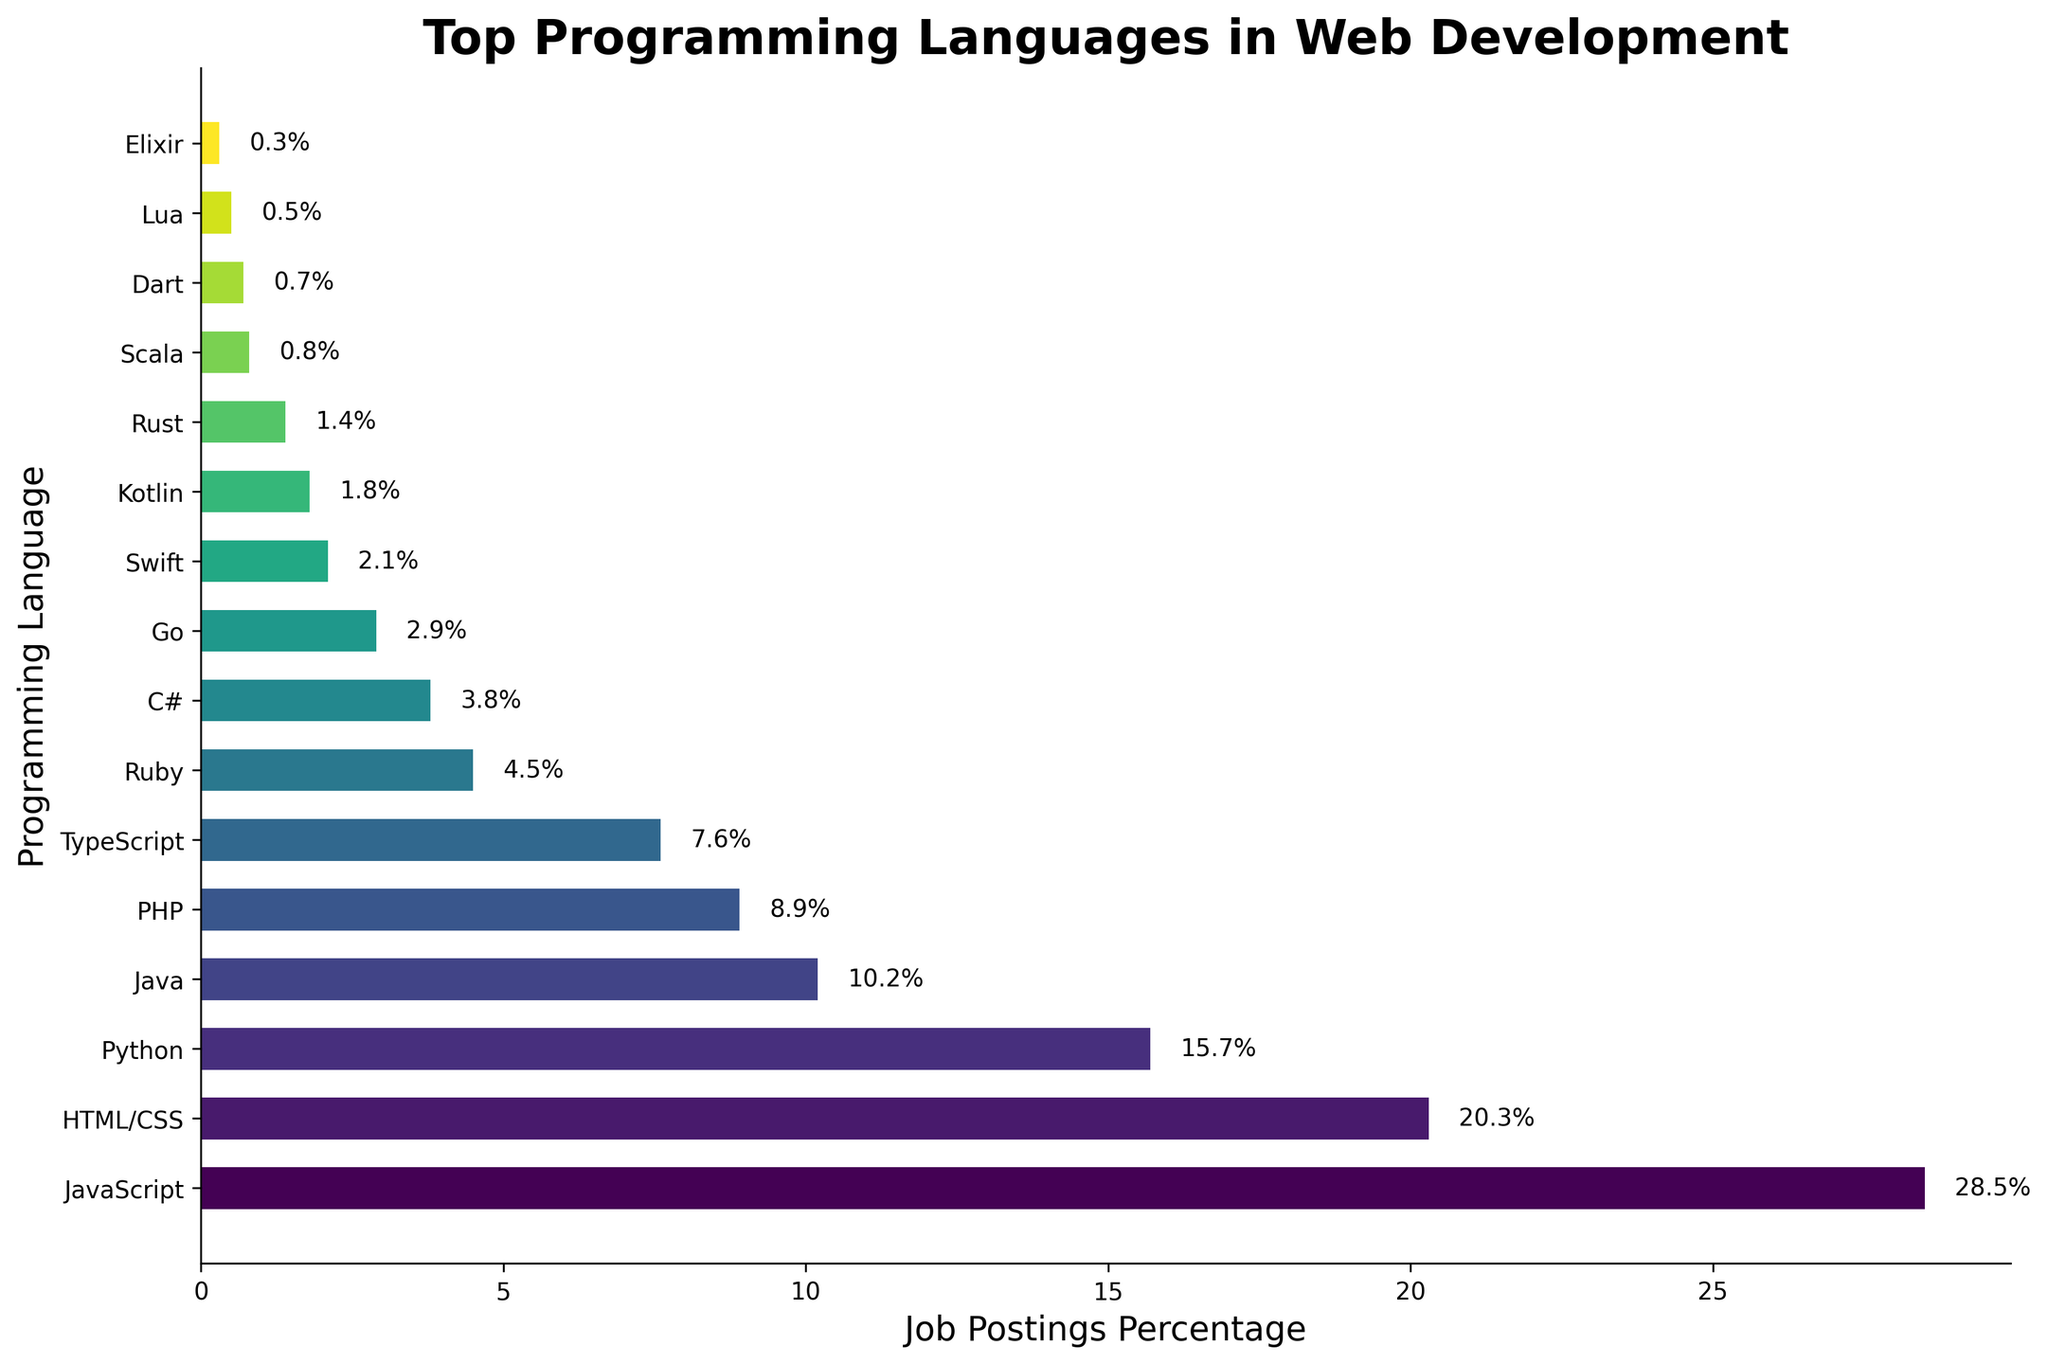Which programming language has the highest percentage of job postings? The figure lists the job postings percentage for each programming language on a horizontal bar chart. The language with the longest bar represents the highest percentage. Here the longest bar corresponds to JavaScript, which has a percentage of 28.5%
Answer: JavaScript Which programming language has the lowest job postings percentage? The shortest bar on the horizontal bar chart represents the lowest job postings percentage. The shortest bar corresponds to Elixir, which has a percentage of 0.3%
Answer: Elixir What is the combined percentage of job postings for Java and Python? To find the combined percentage, add the percentages of Java and Python. Java has 10.2% and Python has 15.7%. Adding these together, 10.2 + 15.7, results in 25.9%
Answer: 25.9% Is the percentage of job postings for TypeScript more or less than PHP? Compare the lengths of the bars for TypeScript and PHP. TypeScript has a percentage of 7.6% while PHP has a percentage of 8.9%. Since 7.6 is less than 8.9, TypeScript has a lower percentage than PHP
Answer: Less Which languages have job posting percentages between 1% and 5%? Identify all bars whose lengths correspond to percentages between 1% and 5%. These languages include Ruby (4.5%), C# (3.8%), Go (2.9%), Swift (2.1%), and Kotlin (1.8%)
Answer: Ruby, C#, Go, Swift, Kotlin How much more is the job postings percentage for JavaScript compared to HTML/CSS? Subtract the percentage of HTML/CSS from the percentage of JavaScript. JavaScript has 28.5% and HTML/CSS has 20.3%. Subtracting these, 28.5 - 20.3, results in 8.2%
Answer: 8.2% What is the median percentage of job postings among all the programming languages listed? List the percentages in ascending order and find the middle value. The sorted percentages are 0.3, 0.5, 0.7, 0.8, 1.4, 1.8, 2.1, 2.9, 3.8, 4.5, 7.6, 8.9, 10.2, 15.7, 20.3, 28.5. With 16 values, the median is the average of the 8th and 9th values: (2.9 + 3.8) / 2 = 3.35
Answer: 3.35 How does the job postings percentage for Python compare to Java? Compare the lengths of the bars for Python and Java. Python has a percentage of 15.7%, and Java has a percentage of 10.2%. Since 15.7 is greater than 10.2, Python has a higher percentage than Java
Answer: Python is higher Which language is exactly in the middle in terms of job postings percentage? Arrange the languages in order of their job postings percentage and find the one at the middle position. With 16 languages, the middle would be the 8th and 9th, which are Go (2.9%) and C# (3.8%), but there is no single middle language due to there being an even number of languages.
Answer: N/A 